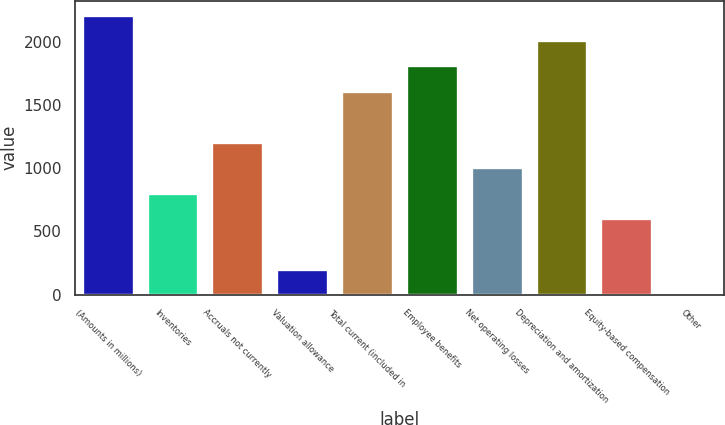Convert chart to OTSL. <chart><loc_0><loc_0><loc_500><loc_500><bar_chart><fcel>(Amounts in millions)<fcel>Inventories<fcel>Accruals not currently<fcel>Valuation allowance<fcel>Total current (included in<fcel>Employee benefits<fcel>Net operating losses<fcel>Depreciation and amortization<fcel>Equity-based compensation<fcel>Other<nl><fcel>2213.16<fcel>805.04<fcel>1207.36<fcel>201.56<fcel>1609.68<fcel>1810.84<fcel>1006.2<fcel>2012<fcel>603.88<fcel>0.4<nl></chart> 